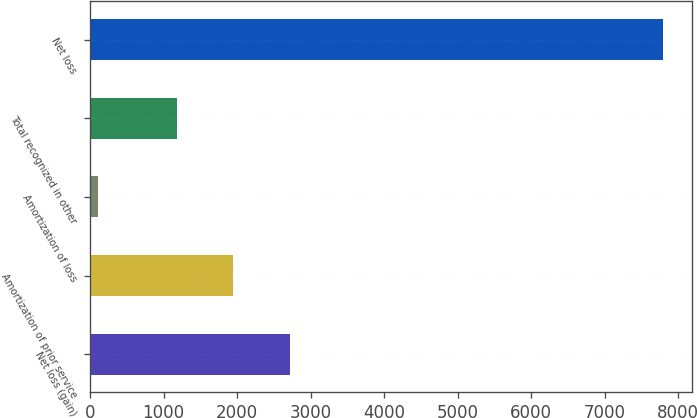Convert chart. <chart><loc_0><loc_0><loc_500><loc_500><bar_chart><fcel>Net loss (gain)<fcel>Amortization of prior service<fcel>Amortization of loss<fcel>Total recognized in other<fcel>Net loss<nl><fcel>2715.4<fcel>1946.7<fcel>106<fcel>1178<fcel>7793<nl></chart> 